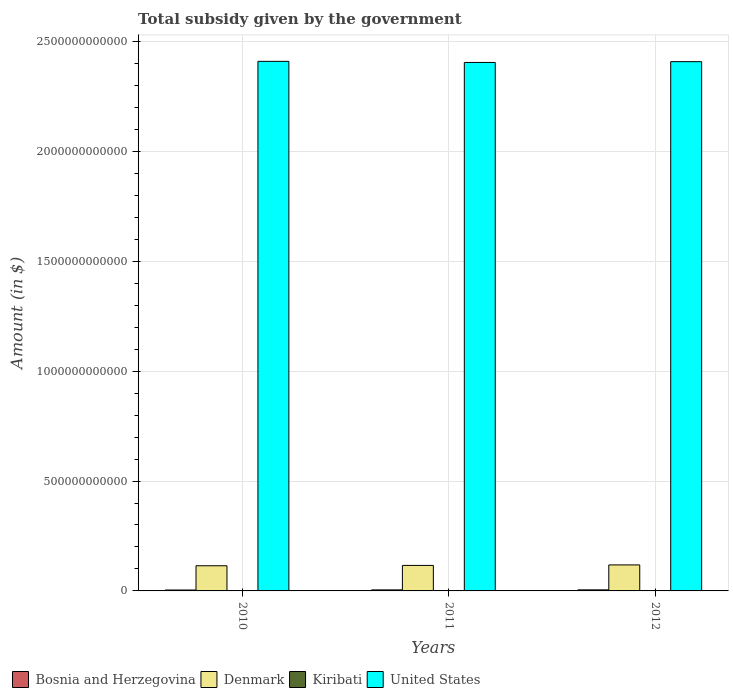How many different coloured bars are there?
Provide a short and direct response. 4. How many groups of bars are there?
Provide a short and direct response. 3. Are the number of bars per tick equal to the number of legend labels?
Provide a succinct answer. Yes. Are the number of bars on each tick of the X-axis equal?
Your response must be concise. Yes. How many bars are there on the 1st tick from the right?
Offer a very short reply. 4. What is the label of the 1st group of bars from the left?
Offer a terse response. 2010. In how many cases, is the number of bars for a given year not equal to the number of legend labels?
Offer a terse response. 0. What is the total revenue collected by the government in Bosnia and Herzegovina in 2011?
Your answer should be very brief. 4.69e+09. Across all years, what is the maximum total revenue collected by the government in United States?
Give a very brief answer. 2.41e+12. Across all years, what is the minimum total revenue collected by the government in Denmark?
Your response must be concise. 1.15e+11. In which year was the total revenue collected by the government in Bosnia and Herzegovina maximum?
Provide a succinct answer. 2012. What is the total total revenue collected by the government in United States in the graph?
Your answer should be compact. 7.22e+12. What is the difference between the total revenue collected by the government in Denmark in 2011 and that in 2012?
Give a very brief answer. -2.27e+09. What is the difference between the total revenue collected by the government in Bosnia and Herzegovina in 2010 and the total revenue collected by the government in Denmark in 2012?
Offer a terse response. -1.14e+11. What is the average total revenue collected by the government in Kiribati per year?
Keep it short and to the point. 9.92e+06. In the year 2011, what is the difference between the total revenue collected by the government in Bosnia and Herzegovina and total revenue collected by the government in Kiribati?
Offer a very short reply. 4.67e+09. In how many years, is the total revenue collected by the government in United States greater than 1800000000000 $?
Your answer should be compact. 3. What is the ratio of the total revenue collected by the government in Kiribati in 2010 to that in 2011?
Your answer should be very brief. 0.65. What is the difference between the highest and the second highest total revenue collected by the government in Denmark?
Provide a succinct answer. 2.27e+09. What is the difference between the highest and the lowest total revenue collected by the government in Denmark?
Provide a short and direct response. 3.80e+09. What does the 1st bar from the left in 2010 represents?
Your answer should be compact. Bosnia and Herzegovina. Is it the case that in every year, the sum of the total revenue collected by the government in Kiribati and total revenue collected by the government in United States is greater than the total revenue collected by the government in Denmark?
Make the answer very short. Yes. Are all the bars in the graph horizontal?
Offer a very short reply. No. How many years are there in the graph?
Keep it short and to the point. 3. What is the difference between two consecutive major ticks on the Y-axis?
Ensure brevity in your answer.  5.00e+11. Are the values on the major ticks of Y-axis written in scientific E-notation?
Offer a very short reply. No. Does the graph contain grids?
Your answer should be compact. Yes. Where does the legend appear in the graph?
Your answer should be compact. Bottom left. How many legend labels are there?
Provide a short and direct response. 4. How are the legend labels stacked?
Give a very brief answer. Horizontal. What is the title of the graph?
Ensure brevity in your answer.  Total subsidy given by the government. Does "Barbados" appear as one of the legend labels in the graph?
Provide a short and direct response. No. What is the label or title of the Y-axis?
Provide a short and direct response. Amount (in $). What is the Amount (in $) in Bosnia and Herzegovina in 2010?
Make the answer very short. 4.18e+09. What is the Amount (in $) in Denmark in 2010?
Keep it short and to the point. 1.15e+11. What is the Amount (in $) in Kiribati in 2010?
Provide a short and direct response. 9.01e+06. What is the Amount (in $) in United States in 2010?
Your answer should be compact. 2.41e+12. What is the Amount (in $) of Bosnia and Herzegovina in 2011?
Offer a terse response. 4.69e+09. What is the Amount (in $) in Denmark in 2011?
Offer a very short reply. 1.16e+11. What is the Amount (in $) of Kiribati in 2011?
Provide a succinct answer. 1.39e+07. What is the Amount (in $) of United States in 2011?
Keep it short and to the point. 2.40e+12. What is the Amount (in $) in Bosnia and Herzegovina in 2012?
Ensure brevity in your answer.  4.76e+09. What is the Amount (in $) in Denmark in 2012?
Offer a very short reply. 1.18e+11. What is the Amount (in $) in Kiribati in 2012?
Provide a succinct answer. 6.83e+06. What is the Amount (in $) in United States in 2012?
Provide a succinct answer. 2.41e+12. Across all years, what is the maximum Amount (in $) of Bosnia and Herzegovina?
Offer a terse response. 4.76e+09. Across all years, what is the maximum Amount (in $) in Denmark?
Make the answer very short. 1.18e+11. Across all years, what is the maximum Amount (in $) of Kiribati?
Offer a very short reply. 1.39e+07. Across all years, what is the maximum Amount (in $) in United States?
Keep it short and to the point. 2.41e+12. Across all years, what is the minimum Amount (in $) of Bosnia and Herzegovina?
Ensure brevity in your answer.  4.18e+09. Across all years, what is the minimum Amount (in $) of Denmark?
Make the answer very short. 1.15e+11. Across all years, what is the minimum Amount (in $) in Kiribati?
Ensure brevity in your answer.  6.83e+06. Across all years, what is the minimum Amount (in $) in United States?
Your response must be concise. 2.40e+12. What is the total Amount (in $) of Bosnia and Herzegovina in the graph?
Provide a short and direct response. 1.36e+1. What is the total Amount (in $) of Denmark in the graph?
Provide a succinct answer. 3.49e+11. What is the total Amount (in $) in Kiribati in the graph?
Make the answer very short. 2.98e+07. What is the total Amount (in $) of United States in the graph?
Your answer should be compact. 7.22e+12. What is the difference between the Amount (in $) of Bosnia and Herzegovina in 2010 and that in 2011?
Your response must be concise. -5.11e+08. What is the difference between the Amount (in $) of Denmark in 2010 and that in 2011?
Give a very brief answer. -1.53e+09. What is the difference between the Amount (in $) in Kiribati in 2010 and that in 2011?
Your answer should be compact. -4.91e+06. What is the difference between the Amount (in $) of Bosnia and Herzegovina in 2010 and that in 2012?
Give a very brief answer. -5.86e+08. What is the difference between the Amount (in $) of Denmark in 2010 and that in 2012?
Provide a short and direct response. -3.80e+09. What is the difference between the Amount (in $) in Kiribati in 2010 and that in 2012?
Give a very brief answer. 2.17e+06. What is the difference between the Amount (in $) of United States in 2010 and that in 2012?
Offer a terse response. 1.40e+09. What is the difference between the Amount (in $) of Bosnia and Herzegovina in 2011 and that in 2012?
Offer a terse response. -7.54e+07. What is the difference between the Amount (in $) of Denmark in 2011 and that in 2012?
Provide a short and direct response. -2.27e+09. What is the difference between the Amount (in $) in Kiribati in 2011 and that in 2012?
Make the answer very short. 7.08e+06. What is the difference between the Amount (in $) of United States in 2011 and that in 2012?
Make the answer very short. -3.60e+09. What is the difference between the Amount (in $) in Bosnia and Herzegovina in 2010 and the Amount (in $) in Denmark in 2011?
Your response must be concise. -1.12e+11. What is the difference between the Amount (in $) of Bosnia and Herzegovina in 2010 and the Amount (in $) of Kiribati in 2011?
Ensure brevity in your answer.  4.16e+09. What is the difference between the Amount (in $) in Bosnia and Herzegovina in 2010 and the Amount (in $) in United States in 2011?
Make the answer very short. -2.40e+12. What is the difference between the Amount (in $) of Denmark in 2010 and the Amount (in $) of Kiribati in 2011?
Offer a very short reply. 1.14e+11. What is the difference between the Amount (in $) in Denmark in 2010 and the Amount (in $) in United States in 2011?
Provide a short and direct response. -2.29e+12. What is the difference between the Amount (in $) of Kiribati in 2010 and the Amount (in $) of United States in 2011?
Provide a short and direct response. -2.40e+12. What is the difference between the Amount (in $) of Bosnia and Herzegovina in 2010 and the Amount (in $) of Denmark in 2012?
Provide a short and direct response. -1.14e+11. What is the difference between the Amount (in $) in Bosnia and Herzegovina in 2010 and the Amount (in $) in Kiribati in 2012?
Offer a very short reply. 4.17e+09. What is the difference between the Amount (in $) of Bosnia and Herzegovina in 2010 and the Amount (in $) of United States in 2012?
Provide a short and direct response. -2.40e+12. What is the difference between the Amount (in $) in Denmark in 2010 and the Amount (in $) in Kiribati in 2012?
Your response must be concise. 1.15e+11. What is the difference between the Amount (in $) of Denmark in 2010 and the Amount (in $) of United States in 2012?
Ensure brevity in your answer.  -2.29e+12. What is the difference between the Amount (in $) of Kiribati in 2010 and the Amount (in $) of United States in 2012?
Your response must be concise. -2.41e+12. What is the difference between the Amount (in $) of Bosnia and Herzegovina in 2011 and the Amount (in $) of Denmark in 2012?
Provide a succinct answer. -1.14e+11. What is the difference between the Amount (in $) in Bosnia and Herzegovina in 2011 and the Amount (in $) in Kiribati in 2012?
Your answer should be compact. 4.68e+09. What is the difference between the Amount (in $) in Bosnia and Herzegovina in 2011 and the Amount (in $) in United States in 2012?
Your answer should be compact. -2.40e+12. What is the difference between the Amount (in $) of Denmark in 2011 and the Amount (in $) of Kiribati in 2012?
Your response must be concise. 1.16e+11. What is the difference between the Amount (in $) in Denmark in 2011 and the Amount (in $) in United States in 2012?
Your response must be concise. -2.29e+12. What is the difference between the Amount (in $) in Kiribati in 2011 and the Amount (in $) in United States in 2012?
Offer a very short reply. -2.41e+12. What is the average Amount (in $) in Bosnia and Herzegovina per year?
Give a very brief answer. 4.54e+09. What is the average Amount (in $) in Denmark per year?
Offer a terse response. 1.16e+11. What is the average Amount (in $) of Kiribati per year?
Offer a terse response. 9.92e+06. What is the average Amount (in $) of United States per year?
Make the answer very short. 2.41e+12. In the year 2010, what is the difference between the Amount (in $) in Bosnia and Herzegovina and Amount (in $) in Denmark?
Your answer should be compact. -1.10e+11. In the year 2010, what is the difference between the Amount (in $) of Bosnia and Herzegovina and Amount (in $) of Kiribati?
Make the answer very short. 4.17e+09. In the year 2010, what is the difference between the Amount (in $) in Bosnia and Herzegovina and Amount (in $) in United States?
Your answer should be very brief. -2.41e+12. In the year 2010, what is the difference between the Amount (in $) in Denmark and Amount (in $) in Kiribati?
Keep it short and to the point. 1.15e+11. In the year 2010, what is the difference between the Amount (in $) in Denmark and Amount (in $) in United States?
Ensure brevity in your answer.  -2.29e+12. In the year 2010, what is the difference between the Amount (in $) of Kiribati and Amount (in $) of United States?
Keep it short and to the point. -2.41e+12. In the year 2011, what is the difference between the Amount (in $) of Bosnia and Herzegovina and Amount (in $) of Denmark?
Ensure brevity in your answer.  -1.11e+11. In the year 2011, what is the difference between the Amount (in $) of Bosnia and Herzegovina and Amount (in $) of Kiribati?
Provide a succinct answer. 4.67e+09. In the year 2011, what is the difference between the Amount (in $) of Bosnia and Herzegovina and Amount (in $) of United States?
Ensure brevity in your answer.  -2.40e+12. In the year 2011, what is the difference between the Amount (in $) of Denmark and Amount (in $) of Kiribati?
Your answer should be very brief. 1.16e+11. In the year 2011, what is the difference between the Amount (in $) of Denmark and Amount (in $) of United States?
Ensure brevity in your answer.  -2.29e+12. In the year 2011, what is the difference between the Amount (in $) in Kiribati and Amount (in $) in United States?
Your answer should be very brief. -2.40e+12. In the year 2012, what is the difference between the Amount (in $) of Bosnia and Herzegovina and Amount (in $) of Denmark?
Give a very brief answer. -1.14e+11. In the year 2012, what is the difference between the Amount (in $) in Bosnia and Herzegovina and Amount (in $) in Kiribati?
Provide a short and direct response. 4.76e+09. In the year 2012, what is the difference between the Amount (in $) in Bosnia and Herzegovina and Amount (in $) in United States?
Offer a terse response. -2.40e+12. In the year 2012, what is the difference between the Amount (in $) in Denmark and Amount (in $) in Kiribati?
Provide a short and direct response. 1.18e+11. In the year 2012, what is the difference between the Amount (in $) in Denmark and Amount (in $) in United States?
Your answer should be compact. -2.29e+12. In the year 2012, what is the difference between the Amount (in $) in Kiribati and Amount (in $) in United States?
Give a very brief answer. -2.41e+12. What is the ratio of the Amount (in $) in Bosnia and Herzegovina in 2010 to that in 2011?
Give a very brief answer. 0.89. What is the ratio of the Amount (in $) in Denmark in 2010 to that in 2011?
Give a very brief answer. 0.99. What is the ratio of the Amount (in $) in Kiribati in 2010 to that in 2011?
Offer a terse response. 0.65. What is the ratio of the Amount (in $) of United States in 2010 to that in 2011?
Make the answer very short. 1. What is the ratio of the Amount (in $) in Bosnia and Herzegovina in 2010 to that in 2012?
Give a very brief answer. 0.88. What is the ratio of the Amount (in $) of Denmark in 2010 to that in 2012?
Provide a short and direct response. 0.97. What is the ratio of the Amount (in $) in Kiribati in 2010 to that in 2012?
Your answer should be very brief. 1.32. What is the ratio of the Amount (in $) of Bosnia and Herzegovina in 2011 to that in 2012?
Provide a succinct answer. 0.98. What is the ratio of the Amount (in $) in Denmark in 2011 to that in 2012?
Provide a succinct answer. 0.98. What is the ratio of the Amount (in $) in Kiribati in 2011 to that in 2012?
Offer a very short reply. 2.04. What is the difference between the highest and the second highest Amount (in $) in Bosnia and Herzegovina?
Offer a very short reply. 7.54e+07. What is the difference between the highest and the second highest Amount (in $) in Denmark?
Make the answer very short. 2.27e+09. What is the difference between the highest and the second highest Amount (in $) of Kiribati?
Offer a terse response. 4.91e+06. What is the difference between the highest and the second highest Amount (in $) of United States?
Your answer should be compact. 1.40e+09. What is the difference between the highest and the lowest Amount (in $) in Bosnia and Herzegovina?
Provide a short and direct response. 5.86e+08. What is the difference between the highest and the lowest Amount (in $) of Denmark?
Provide a succinct answer. 3.80e+09. What is the difference between the highest and the lowest Amount (in $) of Kiribati?
Give a very brief answer. 7.08e+06. 